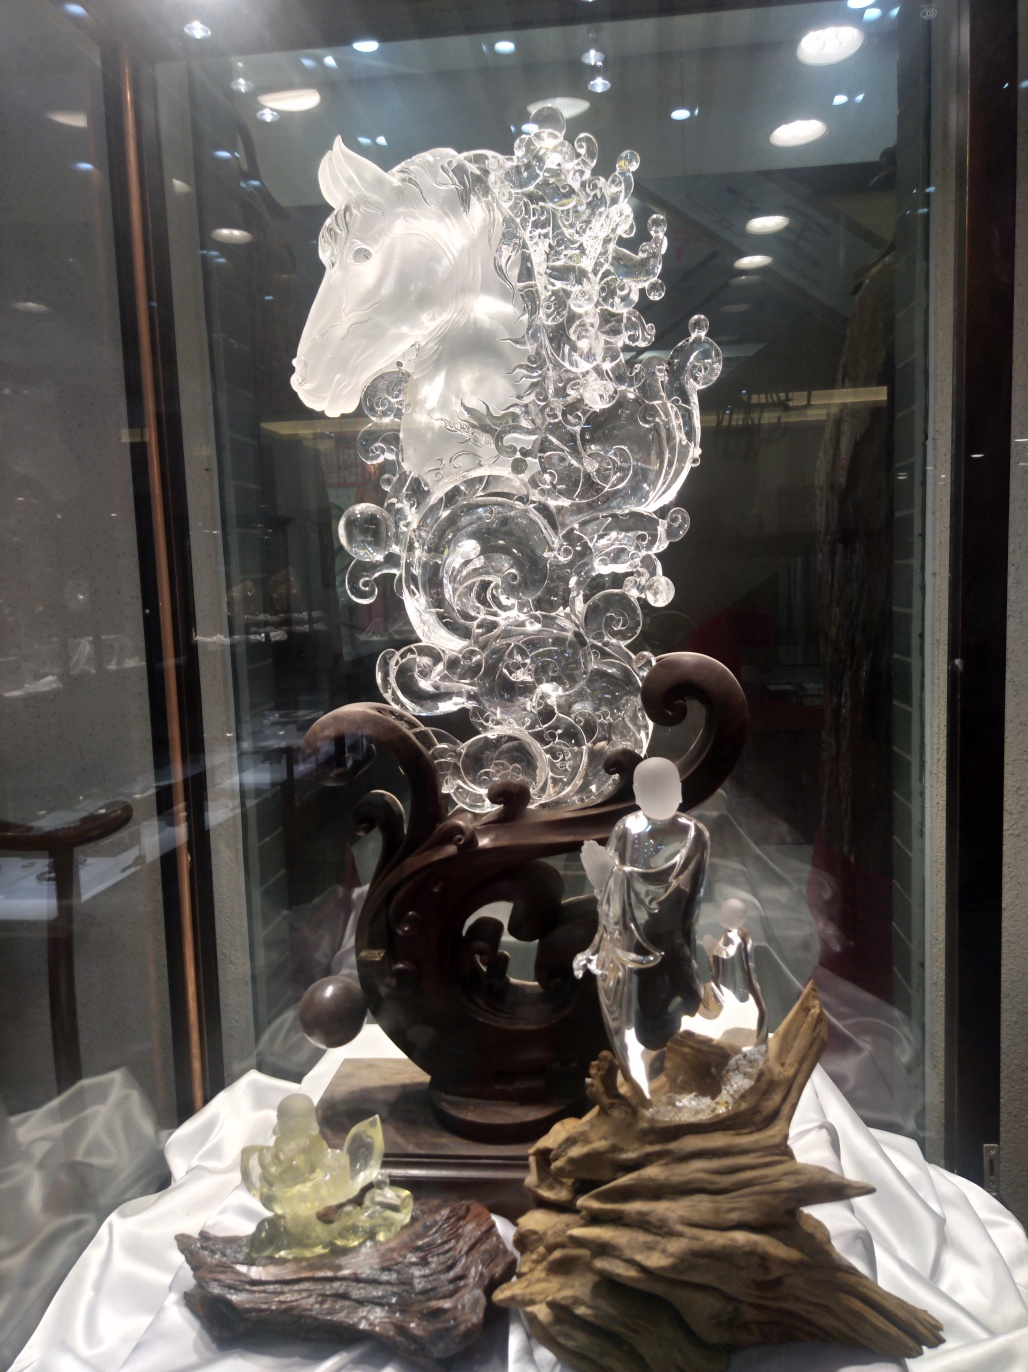Does the image give any clues about the cultural significance of the sculpture? The horse sculpture, combined with the style of the wood stand and accompanying figures, suggest an East Asian cultural influence, perhaps signifying concepts like strength, grace, and prosperity. It may be admired for its aesthetic value as well as its cultural symbolism. 